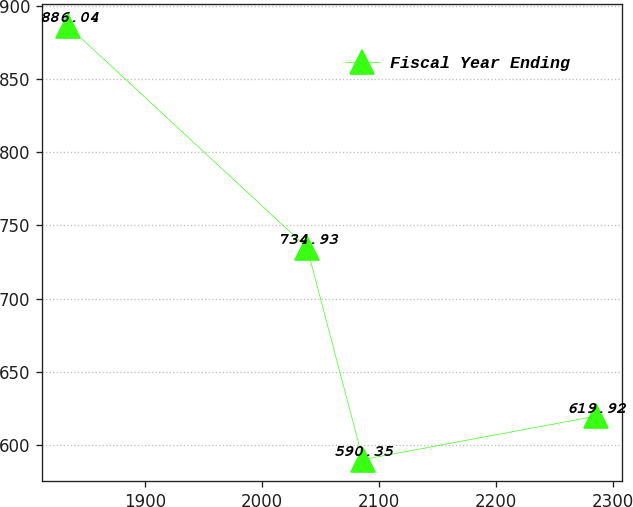<chart> <loc_0><loc_0><loc_500><loc_500><line_chart><ecel><fcel>Fiscal Year Ending<nl><fcel>1834.5<fcel>886.04<nl><fcel>2038.69<fcel>734.93<nl><fcel>2086.42<fcel>590.35<nl><fcel>2285.38<fcel>619.92<nl></chart> 